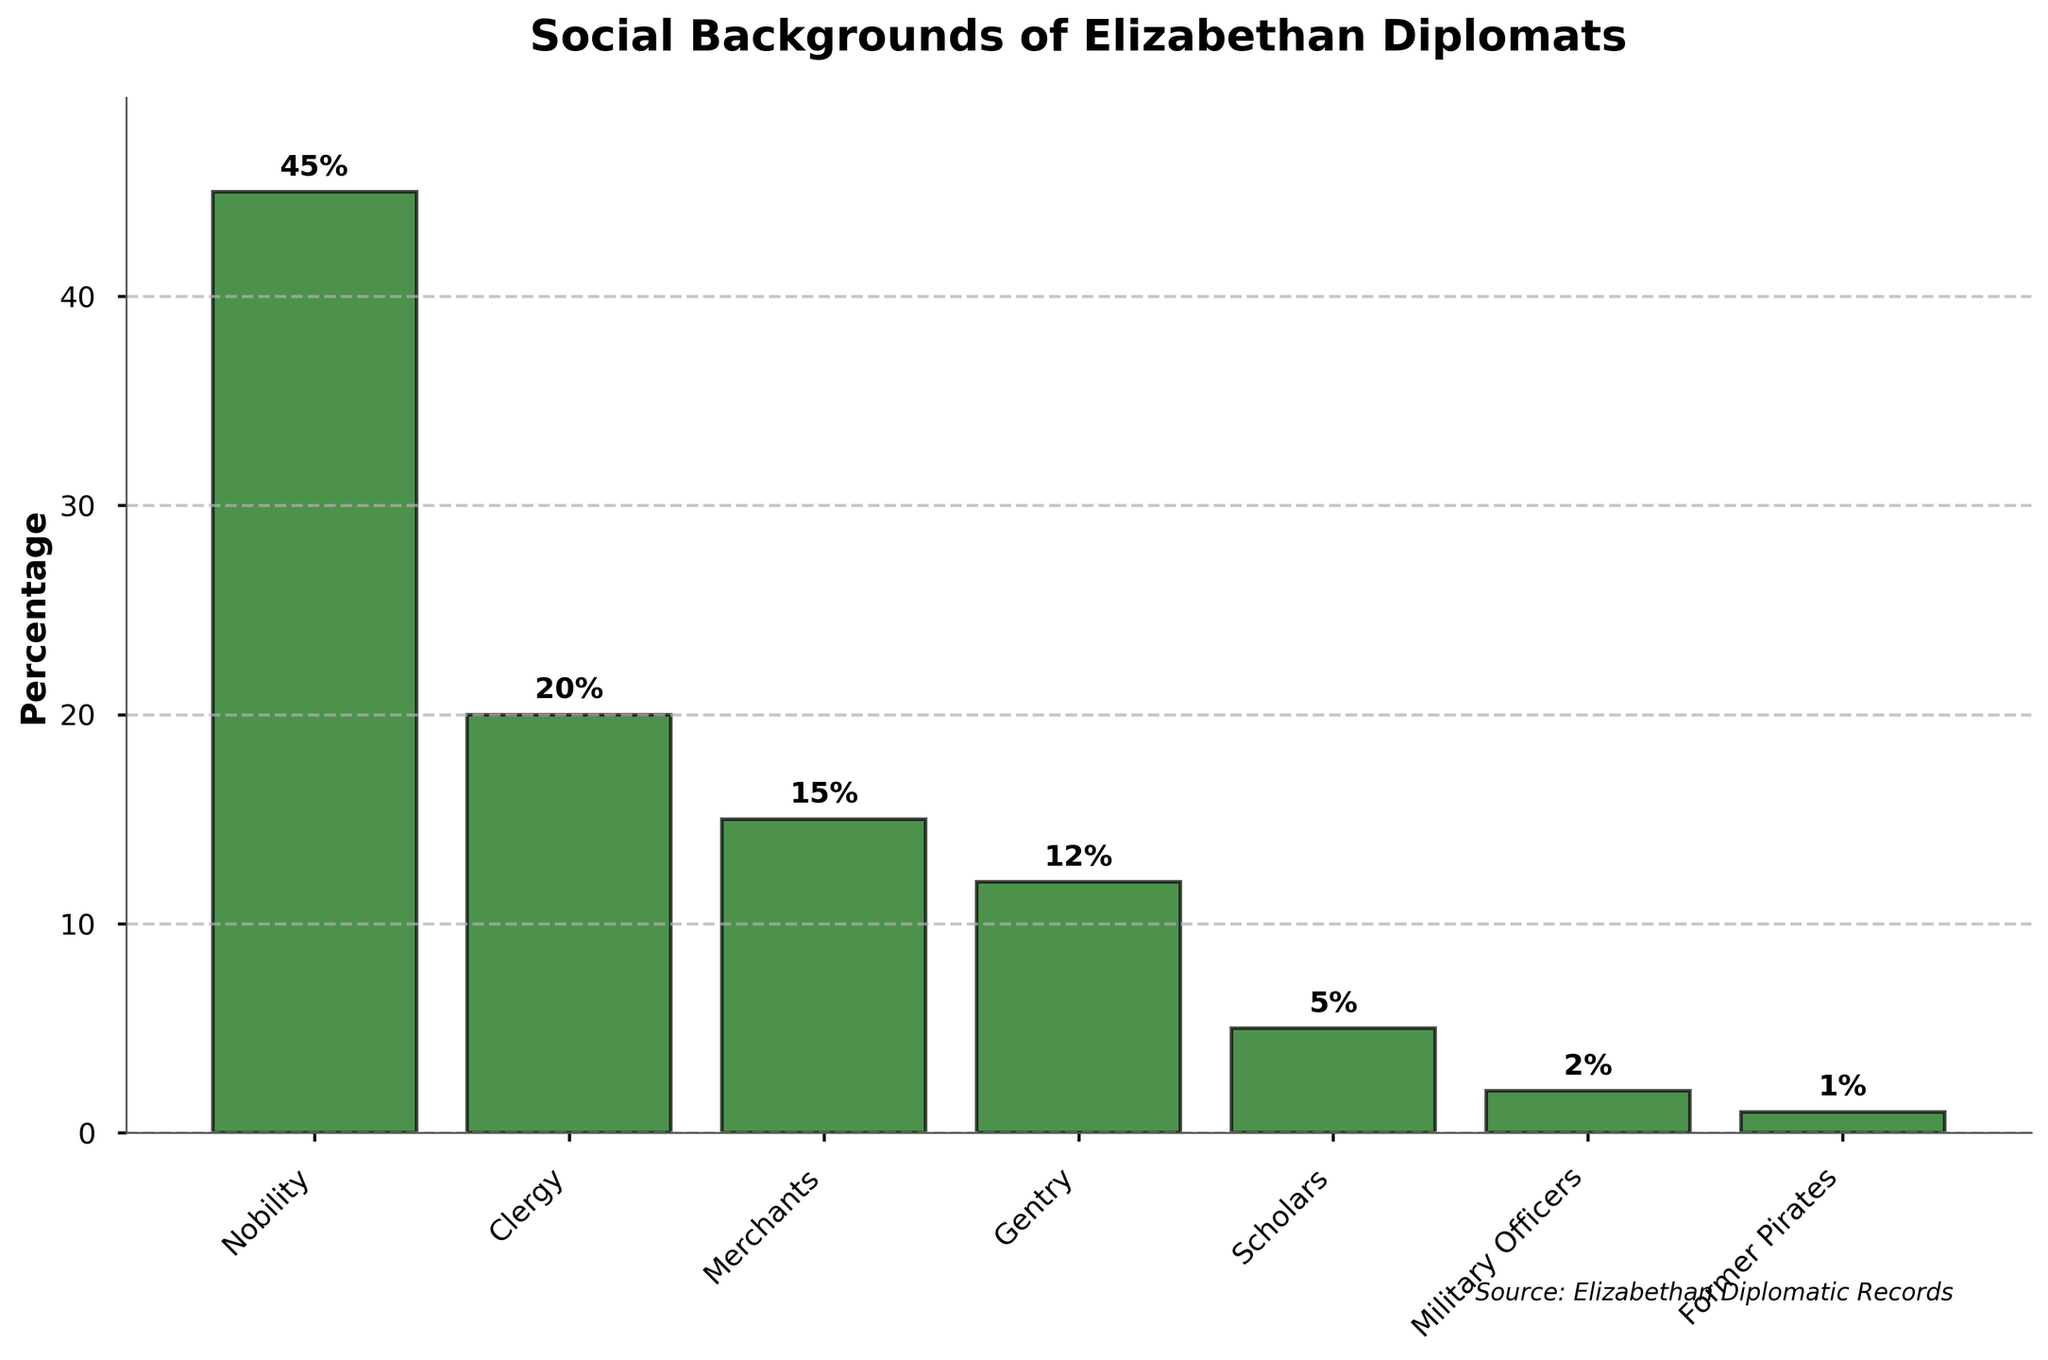What is the social background with the highest percentage of Elizabethan diplomats? The nobility category has the highest bar in the figure, which represents 45%.
Answer: Nobility What is the combined percentage of diplomats from the clergy and merchants? The percentage for the clergy is 20% and for merchants is 15%. Adding these together: 20 + 15 = 35.
Answer: 35% Which social background has a lower percentage of diplomats, merchants or gentry? The merchants have a percentage of 15%, while the gentry has a percentage of 12%. Since 12% is lower than 15%, the gentry have a lower percentage.
Answer: Gentry What is the difference in percentage between the scholars and military officers? The percentage for scholars is 5%, and for military officers, it is 2%. The difference is 5 - 2 = 3.
Answer: 3% What is the total percentage of diplomats coming from the military officers and former pirates combined? The percentage for military officers is 2%, and for former pirates, it is 1%. Adding these together: 2 + 1 = 3.
Answer: 3% Is the percentage of diplomats from the nobility more than double the percentage from the clergy? The percentage for the nobility is 45%, and for the clergy, it is 20%. Double the percentage of the clergy would be 20 * 2 = 40%. Since 45% is greater than 40%, the nobility percentage is indeed more than double that of the clergy.
Answer: Yes Which two categories have the smallest percentages, and what are their values? Former pirates have the smallest percentage at 1%, and military officers have the second smallest at 2%.
Answer: Former Pirates (1%), Military Officers (2%) What is the ratio of the percentage of diplomats from the gentry to the merchants? The percentage for the gentry is 12%, and for merchants, it is 15%. The ratio is 12:15, which can be simplified to 4:5.
Answer: 4:5 What is the average percentage of diplomats from the categories: gentry, scholars, and military officers? The percentages are 12% (gentry), 5% (scholars), and 2% (military officers). The average is calculated as (12 + 5 + 2) / 3 = 19 / 3 ≈ 6.33%.
Answer: 6.33% In terms of percentage, which social background is closest to the average percentage of all the categories combined? Summing up the percentages: 45 (Nobility) + 20 (Clergy) + 15 (Merchants) + 12 (Gentry) + 5 (Scholars) + 2 (Military Officers) + 1 (Former Pirates) = 100. The number of categories is 7, so the average percentage is 100 / 7 ≈ 14.29%. The closest percentage is that of merchants, which is 15%.
Answer: Merchants 